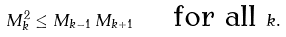<formula> <loc_0><loc_0><loc_500><loc_500>M _ { k } ^ { 2 } \leq M _ { k - 1 } \, M _ { k + 1 } \quad \text { for all } k .</formula> 